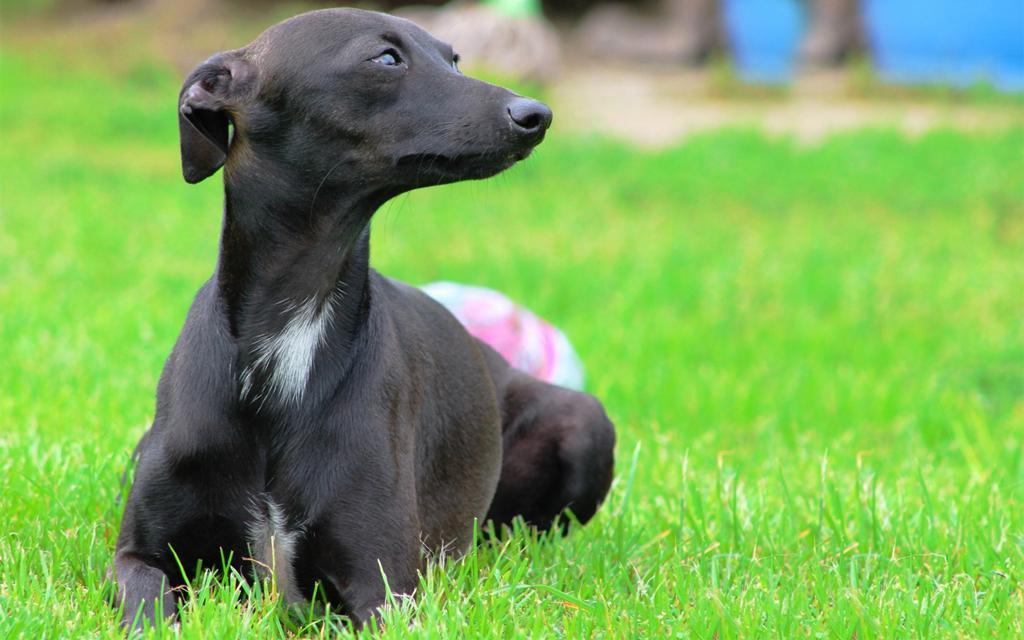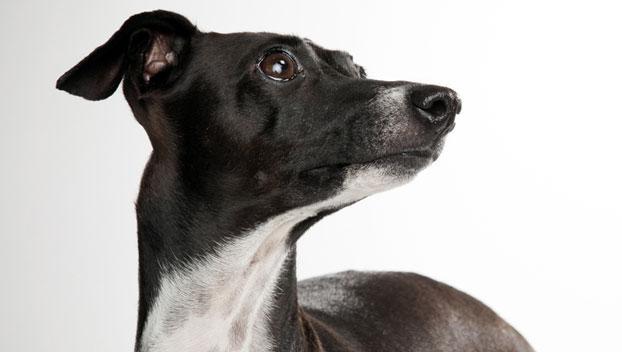The first image is the image on the left, the second image is the image on the right. Analyze the images presented: Is the assertion "The Italian Greyhound dog is standing in each image." valid? Answer yes or no. No. 